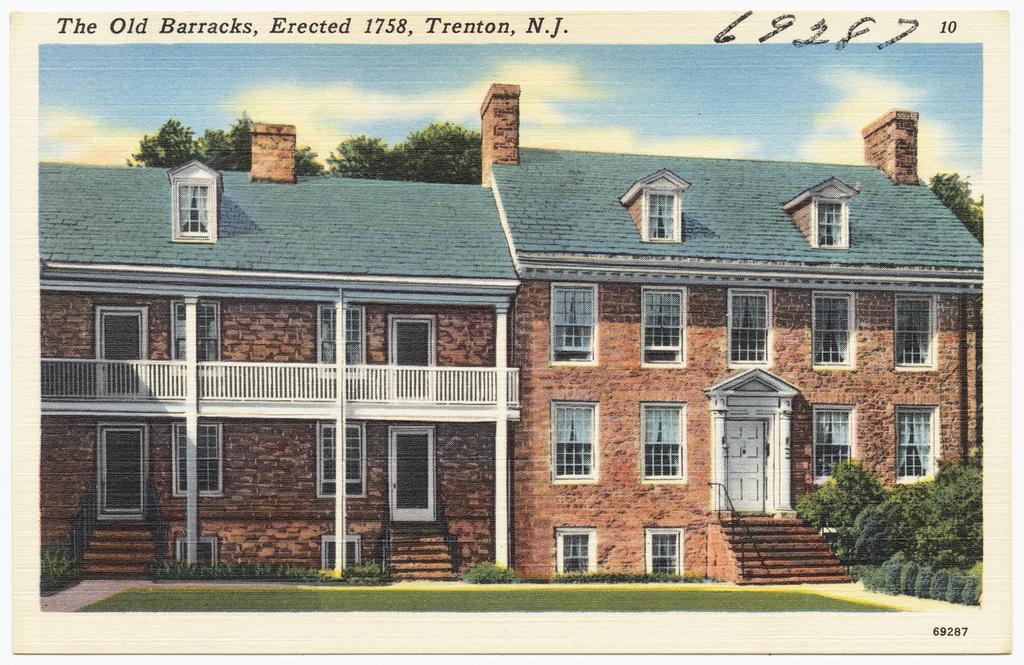How would you summarize this image in a sentence or two? This looks like a poster. I think these are the houses with the windows and doors. I can see the stairs with the staircase holders. These are the trees and bushes. This looks like a grass. Here is the sky. These are the letters in the image. 